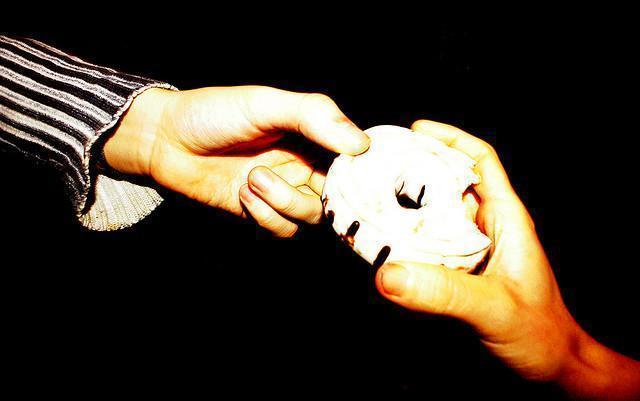Which person bit the donut?
Make your selection and explain in format: 'Answer: answer
Rationale: rationale.'
Options: Leftmost, baker, none, rightmost. Answer: rightmost.
Rationale: Probably the person on the right. 